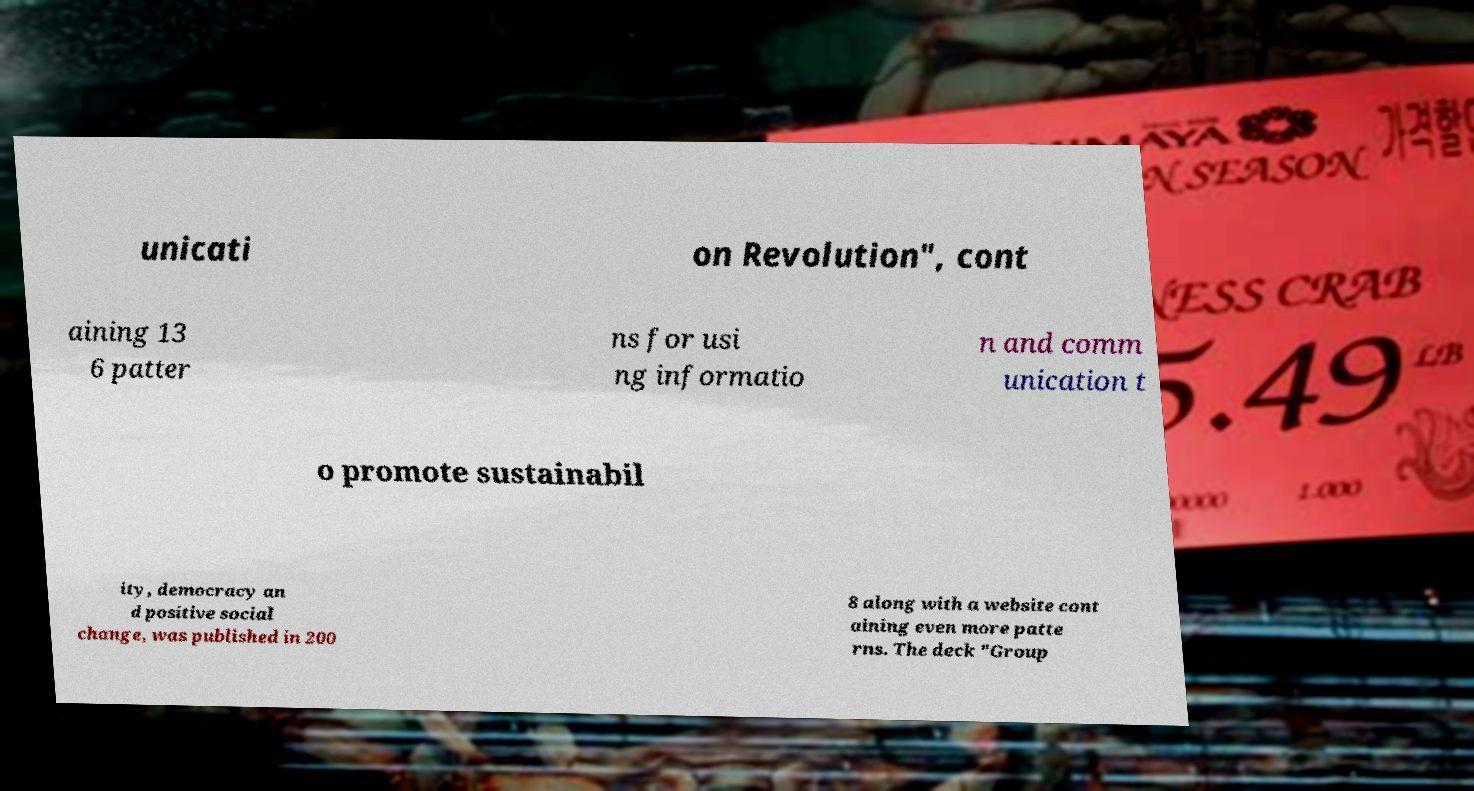There's text embedded in this image that I need extracted. Can you transcribe it verbatim? unicati on Revolution", cont aining 13 6 patter ns for usi ng informatio n and comm unication t o promote sustainabil ity, democracy an d positive social change, was published in 200 8 along with a website cont aining even more patte rns. The deck "Group 